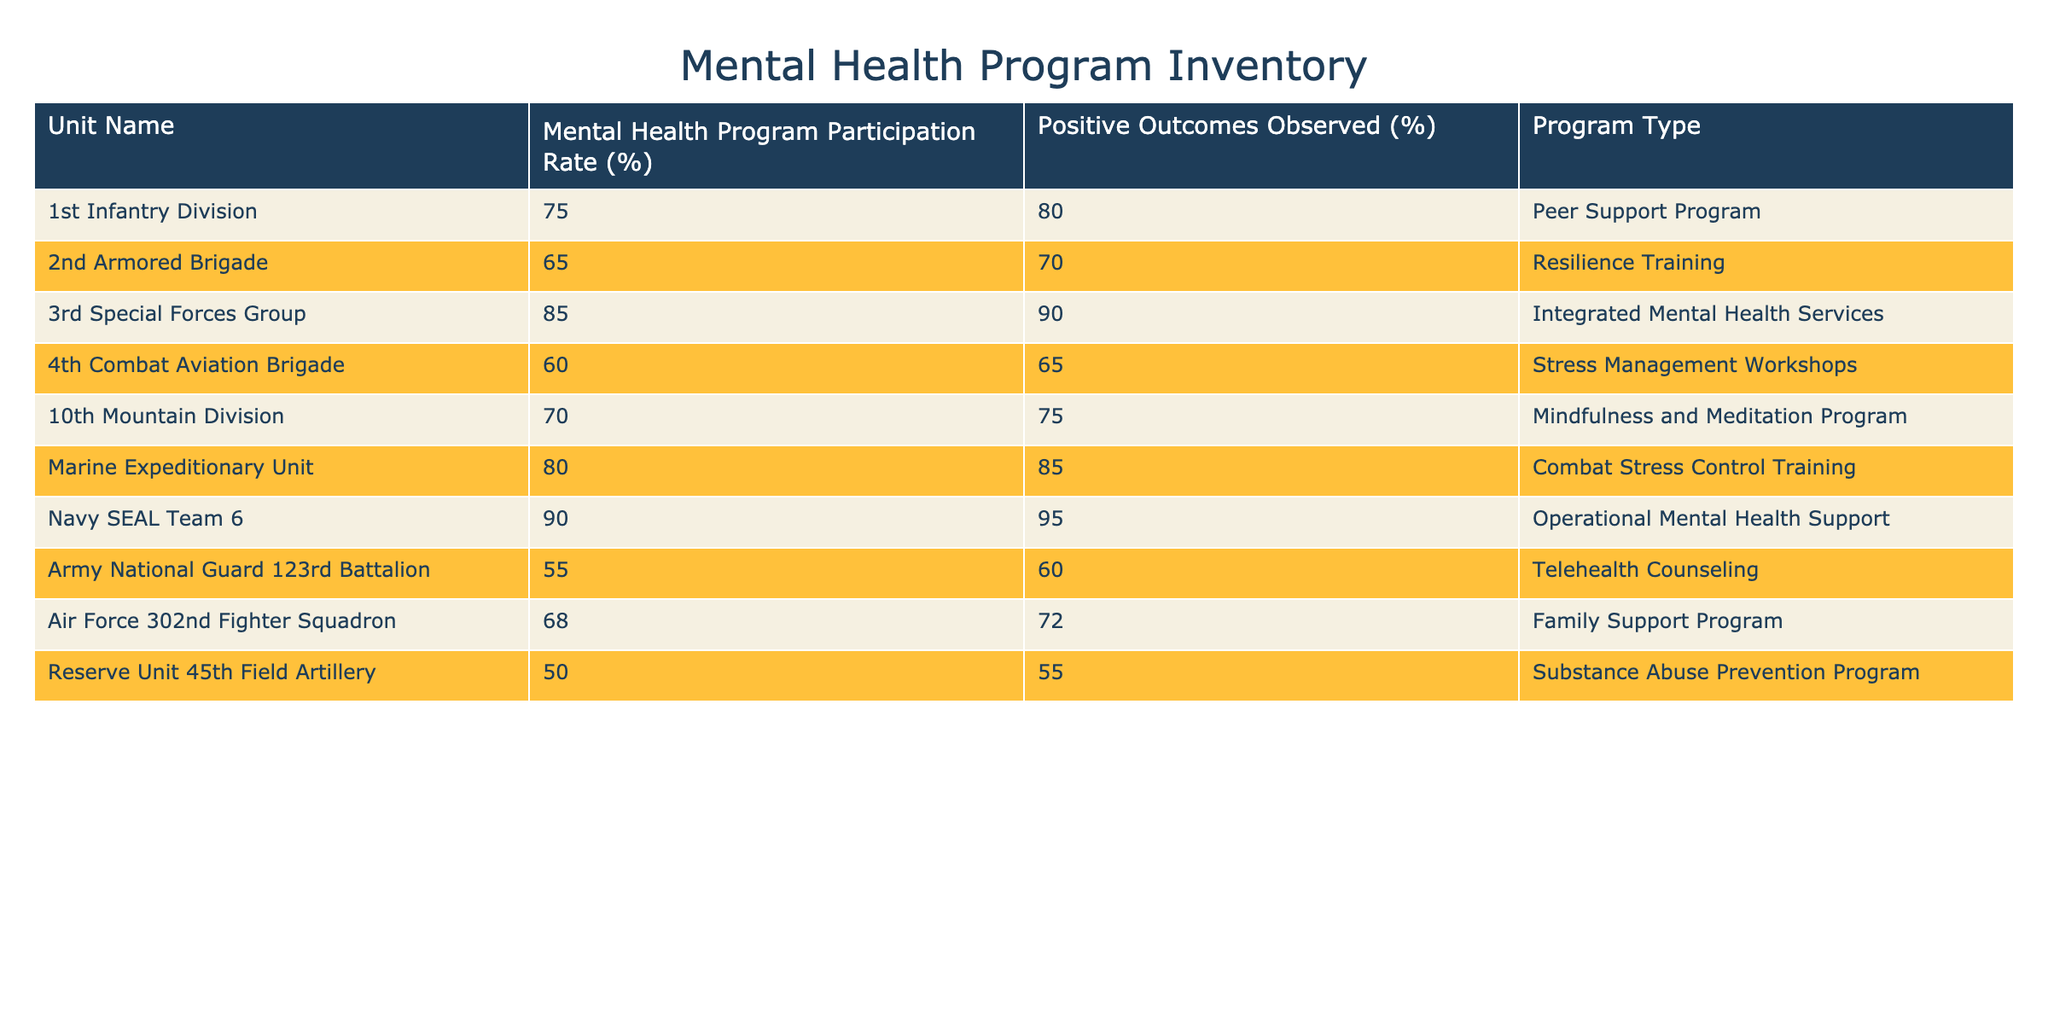What is the participation rate of the Navy SEAL Team 6 in the mental health program? The table shows the participation rate for each unit. Looking at the row for the Navy SEAL Team 6, it indicates a participation rate of 90%.
Answer: 90% Which unit had the lowest mental health program participation rate? The table lists the participation rates for each unit. The lowest rate is found in the Reserve Unit 45th Field Artillery at 50%.
Answer: 50% What is the average participation rate across all units? To find the average, add up all participation rates: (75 + 65 + 85 + 60 + 70 + 80 + 90 + 55 + 68 + 50) =  75.3. Since there are 10 units, divide the total by 10: 753 / 10 = 75.3.
Answer: 75.3% Did the 3rd Special Forces Group achieve a higher positive outcome percentage than the Marine Expeditionary Unit? The positive outcome percentage for the 3rd Special Forces Group is 90% and for the Marine Expeditionary Unit, it is 85%. Since 90% is greater than 85%, the statement is true.
Answer: Yes How many units have a participation rate above 70%? By scanning the table, you can identify units with participation rates above 70%. Those units are: 1st Infantry Division (75%), 3rd Special Forces Group (85%), Marine Expeditionary Unit (80%), and Navy SEAL Team 6 (90%). That totals 4 units.
Answer: 4 What is the difference in positive outcomes observed between the Army National Guard 123rd Battalion and the 4th Combat Aviation Brigade? The positive outcomes observed for the Army National Guard 123rd Battalion is 60% and for the 4th Combat Aviation Brigade, it is 65%. The difference is calculated as 65% - 60% = 5%.
Answer: 5% Which program type corresponds with the unit that achieved the highest mental health program participation rate? The unit with the highest participation rate is the Navy SEAL Team 6 at 90%, which corresponds to the program type "Operational Mental Health Support."
Answer: Operational Mental Health Support Is it true that all units have a positive outcome rate of at least 60%? By reviewing the positive outcome percentages, the Reserve Unit 45th Field Artillery has a 55% rate, which is below 60%. Therefore, not all units meet this criterion.
Answer: No What is the relationship between mental health program participation rate and positive outcomes observed for the 10th Mountain Division? The 10th Mountain Division has a participation rate of 70% and positive outcomes of 75%. The positive outcomes are 5% higher than the participation rate, indicating a positive relationship in this case.
Answer: Positive relationship 